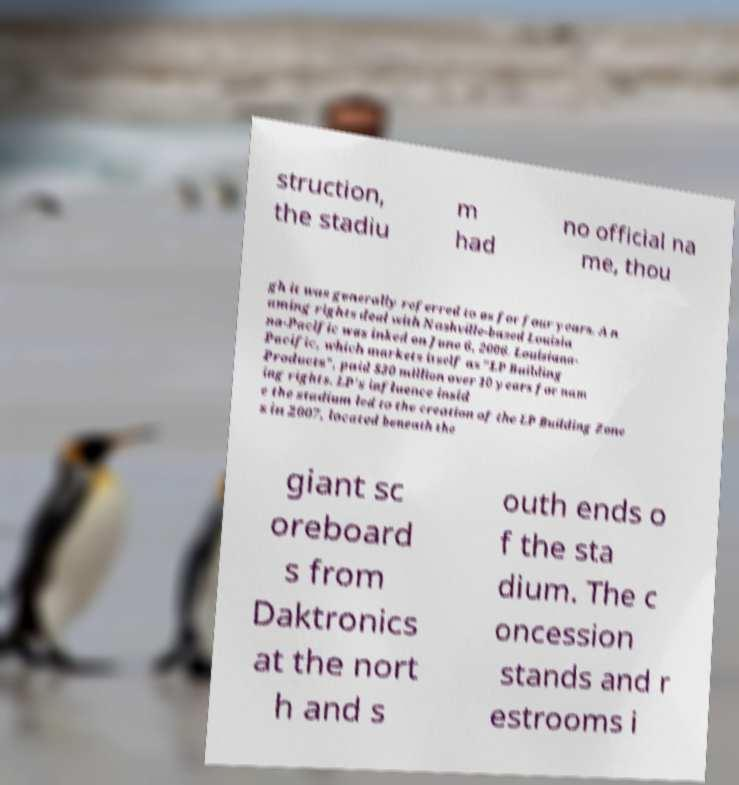What messages or text are displayed in this image? I need them in a readable, typed format. struction, the stadiu m had no official na me, thou gh it was generally referred to as for four years. A n aming rights deal with Nashville-based Louisia na-Pacific was inked on June 6, 2006. Louisiana- Pacific, which markets itself as "LP Building Products", paid $30 million over 10 years for nam ing rights. LP's influence insid e the stadium led to the creation of the LP Building Zone s in 2007, located beneath the giant sc oreboard s from Daktronics at the nort h and s outh ends o f the sta dium. The c oncession stands and r estrooms i 